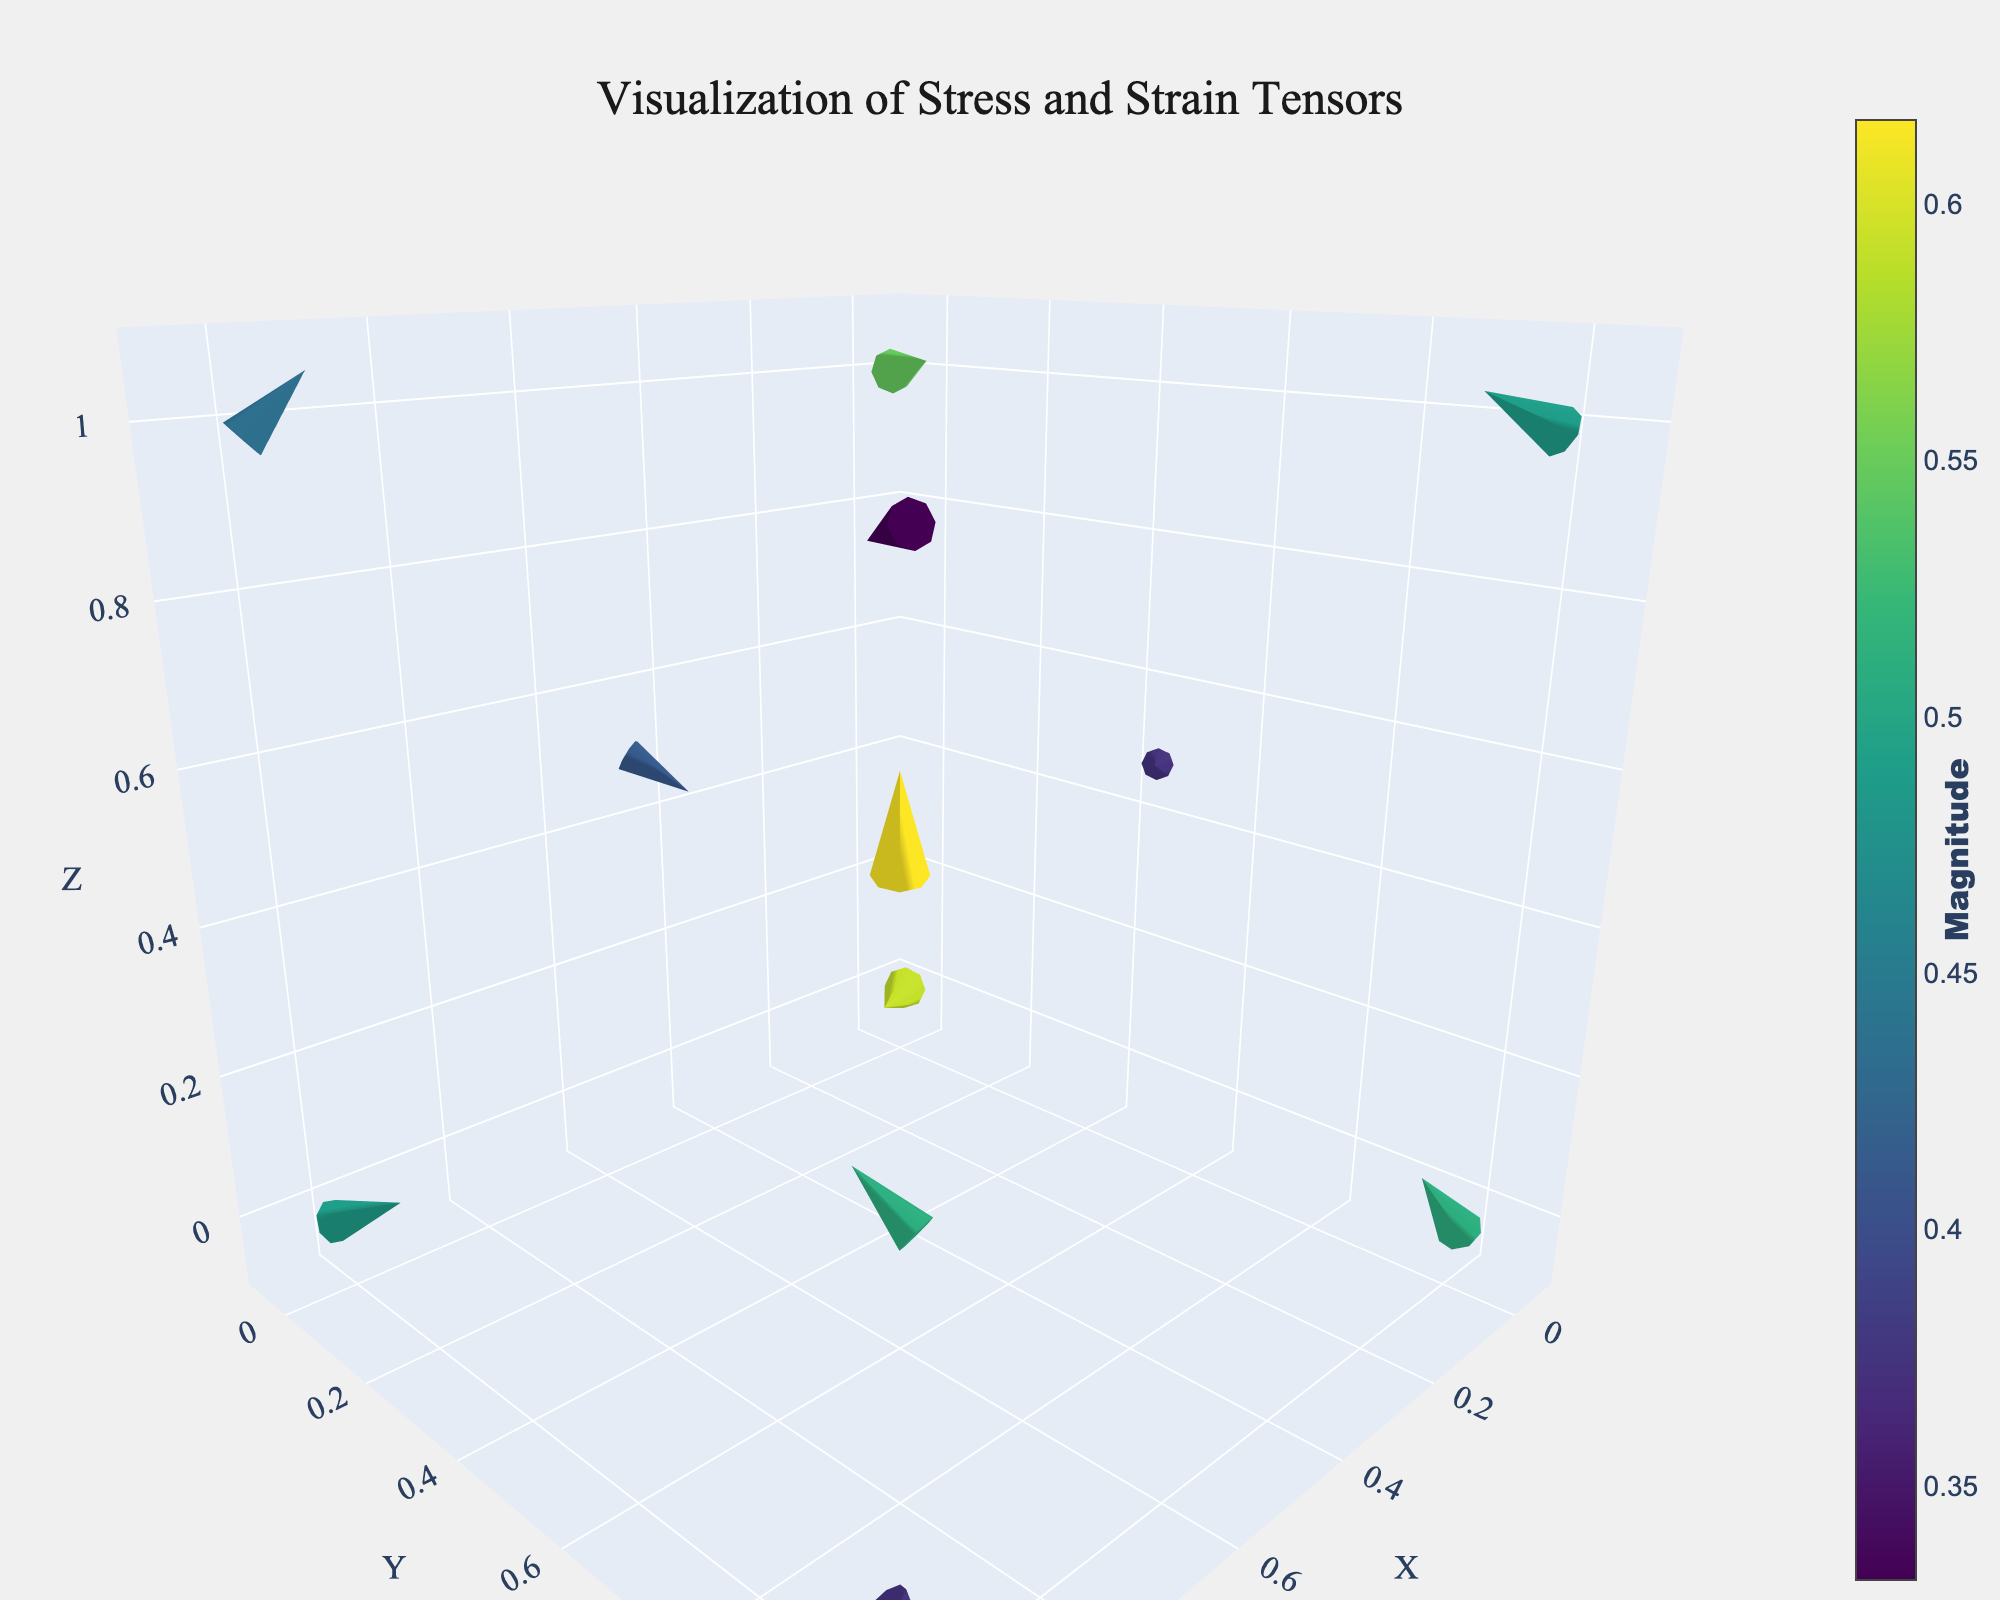How many data points are illustrated in the quiver plot? By visually inspecting the plot, count the total number of cones/arrows. There are 12 cones/arrows, each representing a data point.
Answer: 12 What is the title of the figure? The title is prominently displayed at the top center of the figure. Refer to that section to get the exact wording.
Answer: Visualization of Stress and Strain Tensors What is the range of the z-axis in the figure? Locate the z-axis and read the range values provided along the axis. The z-axis range is specified from -0.1 to 1.1.
Answer: -0.1 to 1.1 Which data point has the highest magnitude? Hovering over each data point will reveal its magnitude. Compare all magnitudes to find the highest value. The highest magnitude is 0.62, located at position (0.5, 0.5, 0.5).
Answer: Point at (0.5, 0.5, 0.5) Compare the magnitudes of the vectors at positions (1,0,0) and (1,1,0). Which one is higher? Hover over the points at positions (1,0,0) and (1,1,0) and note their magnitudes. The magnitudes are 0.49 and 0.37, respectively.
Answer: Position (1,0,0) has a higher magnitude Is there any vector pointing directly upwards along the z-axis? Observe the vectors and identify if any have the direction (u=0, v=0, w>0). None of the vectors point directly upwards along the z-axis, as all vectors have at least one non-zero component in the x or y direction.
Answer: No What is the direction of the vector at position (1,0,1)? Hover over the point at position (1,0,1) and note the vector’s direction components (U,V,W). The components are (-0.3, 0.1, 0.3).
Answer: (-0.3, 0.1, 0.3) Does any vector point directly into the first octant (all positive x, y, z directions)? Examine all vectors and identify if any have positive values for u, v, and w. The vector at (0,0,0) has positive components (0.5, 0.3, 0.1), meeting the criteria.
Answer: Yes, at (0,0,0) Which vector has the largest component along the x-axis? Look at the u-component of each vector and identify the largest value. The vector at (0,1,1) has the largest x-component of 0.4.
Answer: (0,1,1) 